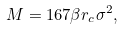Convert formula to latex. <formula><loc_0><loc_0><loc_500><loc_500>M = 1 6 7 \beta r _ { c } \sigma ^ { 2 } ,</formula> 